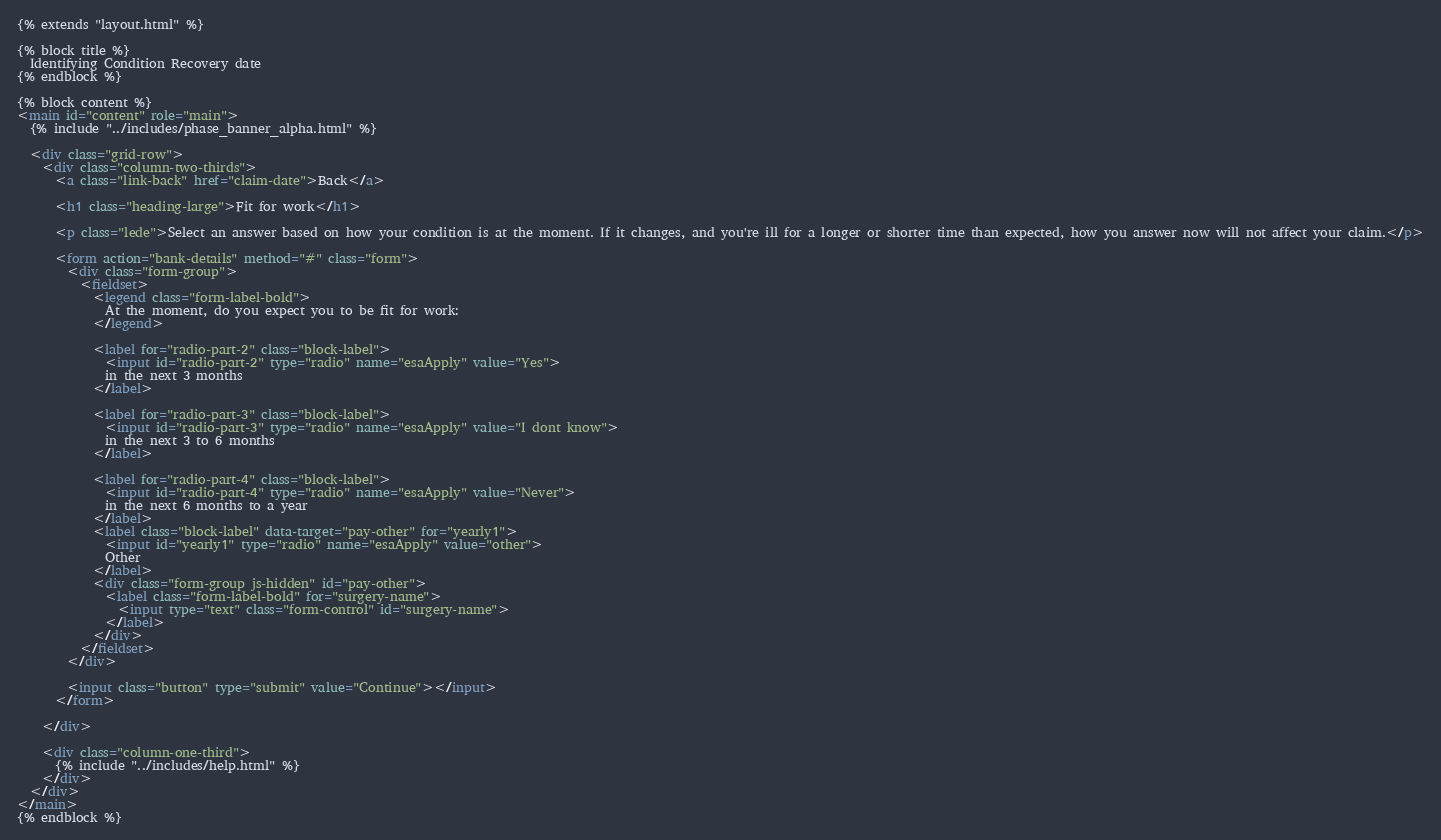Convert code to text. <code><loc_0><loc_0><loc_500><loc_500><_HTML_>{% extends "layout.html" %}

{% block title %}
  Identifying Condition Recovery date
{% endblock %}

{% block content %}
<main id="content" role="main">
  {% include "../includes/phase_banner_alpha.html" %}

  <div class="grid-row">
    <div class="column-two-thirds">
      <a class="link-back" href="claim-date">Back</a>

      <h1 class="heading-large">Fit for work</h1>

      <p class="lede">Select an answer based on how your condition is at the moment. If it changes, and you're ill for a longer or shorter time than expected, how you answer now will not affect your claim.</p>

      <form action="bank-details" method="#" class="form">
        <div class="form-group">
          <fieldset>
            <legend class="form-label-bold">
              At the moment, do you expect you to be fit for work:
            </legend>

            <label for="radio-part-2" class="block-label">
              <input id="radio-part-2" type="radio" name="esaApply" value="Yes">
              in the next 3 months
            </label>

            <label for="radio-part-3" class="block-label">
              <input id="radio-part-3" type="radio" name="esaApply" value="I dont know">
              in the next 3 to 6 months
            </label>

            <label for="radio-part-4" class="block-label">
              <input id="radio-part-4" type="radio" name="esaApply" value="Never">
              in the next 6 months to a year
            </label>
            <label class="block-label" data-target="pay-other" for="yearly1">
              <input id="yearly1" type="radio" name="esaApply" value="other">
              Other
            </label>
            <div class="form-group js-hidden" id="pay-other">
              <label class="form-label-bold" for="surgery-name">
                <input type="text" class="form-control" id="surgery-name">
              </label>
            </div>
          </fieldset>
        </div>

        <input class="button" type="submit" value="Continue"></input>
      </form>

    </div>

    <div class="column-one-third">
      {% include "../includes/help.html" %}
    </div>
  </div>
</main>
{% endblock %}
</code> 